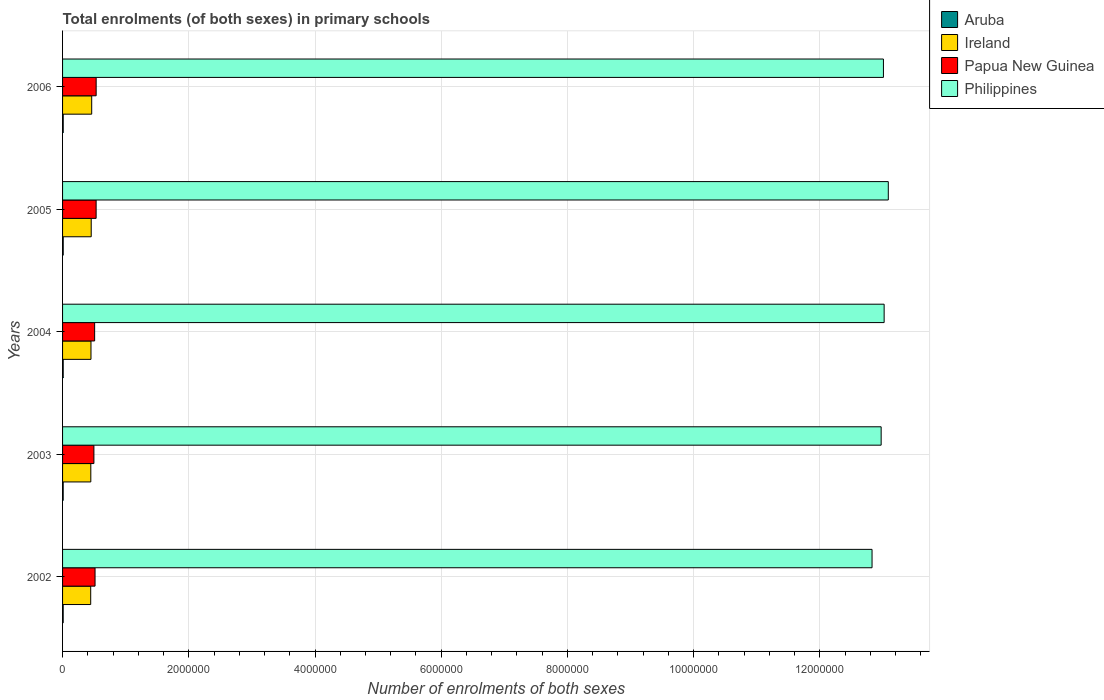How many bars are there on the 1st tick from the top?
Ensure brevity in your answer.  4. How many bars are there on the 2nd tick from the bottom?
Your response must be concise. 4. What is the label of the 3rd group of bars from the top?
Provide a short and direct response. 2004. In how many cases, is the number of bars for a given year not equal to the number of legend labels?
Make the answer very short. 0. What is the number of enrolments in primary schools in Papua New Guinea in 2005?
Keep it short and to the point. 5.32e+05. Across all years, what is the maximum number of enrolments in primary schools in Philippines?
Provide a short and direct response. 1.31e+07. Across all years, what is the minimum number of enrolments in primary schools in Aruba?
Your response must be concise. 9840. What is the total number of enrolments in primary schools in Ireland in the graph?
Offer a very short reply. 2.26e+06. What is the difference between the number of enrolments in primary schools in Philippines in 2002 and that in 2003?
Your answer should be compact. -1.44e+05. What is the difference between the number of enrolments in primary schools in Aruba in 2006 and the number of enrolments in primary schools in Ireland in 2003?
Your response must be concise. -4.37e+05. What is the average number of enrolments in primary schools in Ireland per year?
Your response must be concise. 4.52e+05. In the year 2005, what is the difference between the number of enrolments in primary schools in Papua New Guinea and number of enrolments in primary schools in Ireland?
Provide a succinct answer. 7.77e+04. In how many years, is the number of enrolments in primary schools in Papua New Guinea greater than 10400000 ?
Offer a very short reply. 0. What is the ratio of the number of enrolments in primary schools in Philippines in 2004 to that in 2006?
Your response must be concise. 1. Is the number of enrolments in primary schools in Philippines in 2003 less than that in 2004?
Offer a very short reply. Yes. What is the difference between the highest and the second highest number of enrolments in primary schools in Aruba?
Your answer should be very brief. 140. What is the difference between the highest and the lowest number of enrolments in primary schools in Aruba?
Provide a short and direct response. 550. Is the sum of the number of enrolments in primary schools in Philippines in 2002 and 2006 greater than the maximum number of enrolments in primary schools in Papua New Guinea across all years?
Offer a terse response. Yes. What does the 2nd bar from the top in 2005 represents?
Offer a terse response. Papua New Guinea. What does the 1st bar from the bottom in 2004 represents?
Your answer should be compact. Aruba. Is it the case that in every year, the sum of the number of enrolments in primary schools in Aruba and number of enrolments in primary schools in Ireland is greater than the number of enrolments in primary schools in Papua New Guinea?
Offer a very short reply. No. How many bars are there?
Make the answer very short. 20. Are all the bars in the graph horizontal?
Provide a succinct answer. Yes. How many years are there in the graph?
Give a very brief answer. 5. Does the graph contain any zero values?
Give a very brief answer. No. Where does the legend appear in the graph?
Your answer should be compact. Top right. How are the legend labels stacked?
Make the answer very short. Vertical. What is the title of the graph?
Your answer should be compact. Total enrolments (of both sexes) in primary schools. What is the label or title of the X-axis?
Provide a succinct answer. Number of enrolments of both sexes. What is the label or title of the Y-axis?
Offer a terse response. Years. What is the Number of enrolments of both sexes in Aruba in 2002?
Offer a terse response. 9840. What is the Number of enrolments of both sexes of Ireland in 2002?
Keep it short and to the point. 4.46e+05. What is the Number of enrolments of both sexes of Papua New Guinea in 2002?
Provide a short and direct response. 5.15e+05. What is the Number of enrolments of both sexes in Philippines in 2002?
Keep it short and to the point. 1.28e+07. What is the Number of enrolments of both sexes of Aruba in 2003?
Give a very brief answer. 9897. What is the Number of enrolments of both sexes in Ireland in 2003?
Provide a short and direct response. 4.48e+05. What is the Number of enrolments of both sexes in Papua New Guinea in 2003?
Make the answer very short. 4.97e+05. What is the Number of enrolments of both sexes in Philippines in 2003?
Offer a very short reply. 1.30e+07. What is the Number of enrolments of both sexes in Aruba in 2004?
Offer a terse response. 1.02e+04. What is the Number of enrolments of both sexes in Ireland in 2004?
Make the answer very short. 4.50e+05. What is the Number of enrolments of both sexes in Papua New Guinea in 2004?
Make the answer very short. 5.08e+05. What is the Number of enrolments of both sexes in Philippines in 2004?
Offer a terse response. 1.30e+07. What is the Number of enrolments of both sexes of Aruba in 2005?
Your answer should be very brief. 1.02e+04. What is the Number of enrolments of both sexes of Ireland in 2005?
Give a very brief answer. 4.54e+05. What is the Number of enrolments of both sexes of Papua New Guinea in 2005?
Offer a terse response. 5.32e+05. What is the Number of enrolments of both sexes in Philippines in 2005?
Provide a succinct answer. 1.31e+07. What is the Number of enrolments of both sexes in Aruba in 2006?
Your answer should be compact. 1.04e+04. What is the Number of enrolments of both sexes in Ireland in 2006?
Give a very brief answer. 4.62e+05. What is the Number of enrolments of both sexes of Papua New Guinea in 2006?
Keep it short and to the point. 5.32e+05. What is the Number of enrolments of both sexes of Philippines in 2006?
Your answer should be very brief. 1.30e+07. Across all years, what is the maximum Number of enrolments of both sexes of Aruba?
Offer a terse response. 1.04e+04. Across all years, what is the maximum Number of enrolments of both sexes in Ireland?
Offer a very short reply. 4.62e+05. Across all years, what is the maximum Number of enrolments of both sexes of Papua New Guinea?
Offer a very short reply. 5.32e+05. Across all years, what is the maximum Number of enrolments of both sexes of Philippines?
Give a very brief answer. 1.31e+07. Across all years, what is the minimum Number of enrolments of both sexes of Aruba?
Provide a succinct answer. 9840. Across all years, what is the minimum Number of enrolments of both sexes in Ireland?
Provide a succinct answer. 4.46e+05. Across all years, what is the minimum Number of enrolments of both sexes of Papua New Guinea?
Give a very brief answer. 4.97e+05. Across all years, what is the minimum Number of enrolments of both sexes of Philippines?
Give a very brief answer. 1.28e+07. What is the total Number of enrolments of both sexes in Aruba in the graph?
Ensure brevity in your answer.  5.06e+04. What is the total Number of enrolments of both sexes in Ireland in the graph?
Give a very brief answer. 2.26e+06. What is the total Number of enrolments of both sexes in Papua New Guinea in the graph?
Provide a short and direct response. 2.58e+06. What is the total Number of enrolments of both sexes of Philippines in the graph?
Ensure brevity in your answer.  6.49e+07. What is the difference between the Number of enrolments of both sexes of Aruba in 2002 and that in 2003?
Your answer should be compact. -57. What is the difference between the Number of enrolments of both sexes of Ireland in 2002 and that in 2003?
Give a very brief answer. -1671. What is the difference between the Number of enrolments of both sexes in Papua New Guinea in 2002 and that in 2003?
Provide a short and direct response. 1.81e+04. What is the difference between the Number of enrolments of both sexes of Philippines in 2002 and that in 2003?
Offer a very short reply. -1.44e+05. What is the difference between the Number of enrolments of both sexes in Aruba in 2002 and that in 2004?
Offer a terse response. -345. What is the difference between the Number of enrolments of both sexes in Ireland in 2002 and that in 2004?
Offer a terse response. -4466. What is the difference between the Number of enrolments of both sexes of Papua New Guinea in 2002 and that in 2004?
Provide a short and direct response. 6402. What is the difference between the Number of enrolments of both sexes of Philippines in 2002 and that in 2004?
Give a very brief answer. -1.92e+05. What is the difference between the Number of enrolments of both sexes of Aruba in 2002 and that in 2005?
Provide a succinct answer. -410. What is the difference between the Number of enrolments of both sexes of Ireland in 2002 and that in 2005?
Ensure brevity in your answer.  -8113. What is the difference between the Number of enrolments of both sexes of Papua New Guinea in 2002 and that in 2005?
Provide a short and direct response. -1.70e+04. What is the difference between the Number of enrolments of both sexes in Philippines in 2002 and that in 2005?
Give a very brief answer. -2.58e+05. What is the difference between the Number of enrolments of both sexes in Aruba in 2002 and that in 2006?
Give a very brief answer. -550. What is the difference between the Number of enrolments of both sexes of Ireland in 2002 and that in 2006?
Your response must be concise. -1.56e+04. What is the difference between the Number of enrolments of both sexes of Papua New Guinea in 2002 and that in 2006?
Offer a very short reply. -1.75e+04. What is the difference between the Number of enrolments of both sexes in Philippines in 2002 and that in 2006?
Provide a succinct answer. -1.80e+05. What is the difference between the Number of enrolments of both sexes of Aruba in 2003 and that in 2004?
Keep it short and to the point. -288. What is the difference between the Number of enrolments of both sexes of Ireland in 2003 and that in 2004?
Your response must be concise. -2795. What is the difference between the Number of enrolments of both sexes of Papua New Guinea in 2003 and that in 2004?
Provide a short and direct response. -1.17e+04. What is the difference between the Number of enrolments of both sexes in Philippines in 2003 and that in 2004?
Keep it short and to the point. -4.73e+04. What is the difference between the Number of enrolments of both sexes of Aruba in 2003 and that in 2005?
Provide a succinct answer. -353. What is the difference between the Number of enrolments of both sexes of Ireland in 2003 and that in 2005?
Your answer should be very brief. -6442. What is the difference between the Number of enrolments of both sexes of Papua New Guinea in 2003 and that in 2005?
Provide a short and direct response. -3.51e+04. What is the difference between the Number of enrolments of both sexes in Philippines in 2003 and that in 2005?
Your answer should be compact. -1.13e+05. What is the difference between the Number of enrolments of both sexes of Aruba in 2003 and that in 2006?
Keep it short and to the point. -493. What is the difference between the Number of enrolments of both sexes of Ireland in 2003 and that in 2006?
Make the answer very short. -1.40e+04. What is the difference between the Number of enrolments of both sexes of Papua New Guinea in 2003 and that in 2006?
Give a very brief answer. -3.56e+04. What is the difference between the Number of enrolments of both sexes in Philippines in 2003 and that in 2006?
Offer a terse response. -3.60e+04. What is the difference between the Number of enrolments of both sexes of Aruba in 2004 and that in 2005?
Your response must be concise. -65. What is the difference between the Number of enrolments of both sexes of Ireland in 2004 and that in 2005?
Your answer should be very brief. -3647. What is the difference between the Number of enrolments of both sexes in Papua New Guinea in 2004 and that in 2005?
Provide a short and direct response. -2.34e+04. What is the difference between the Number of enrolments of both sexes in Philippines in 2004 and that in 2005?
Offer a terse response. -6.58e+04. What is the difference between the Number of enrolments of both sexes in Aruba in 2004 and that in 2006?
Offer a terse response. -205. What is the difference between the Number of enrolments of both sexes of Ireland in 2004 and that in 2006?
Your answer should be very brief. -1.12e+04. What is the difference between the Number of enrolments of both sexes in Papua New Guinea in 2004 and that in 2006?
Ensure brevity in your answer.  -2.39e+04. What is the difference between the Number of enrolments of both sexes of Philippines in 2004 and that in 2006?
Provide a succinct answer. 1.13e+04. What is the difference between the Number of enrolments of both sexes in Aruba in 2005 and that in 2006?
Ensure brevity in your answer.  -140. What is the difference between the Number of enrolments of both sexes of Ireland in 2005 and that in 2006?
Your response must be concise. -7528. What is the difference between the Number of enrolments of both sexes in Papua New Guinea in 2005 and that in 2006?
Give a very brief answer. -491. What is the difference between the Number of enrolments of both sexes in Philippines in 2005 and that in 2006?
Your response must be concise. 7.71e+04. What is the difference between the Number of enrolments of both sexes in Aruba in 2002 and the Number of enrolments of both sexes in Ireland in 2003?
Offer a terse response. -4.38e+05. What is the difference between the Number of enrolments of both sexes of Aruba in 2002 and the Number of enrolments of both sexes of Papua New Guinea in 2003?
Your answer should be very brief. -4.87e+05. What is the difference between the Number of enrolments of both sexes of Aruba in 2002 and the Number of enrolments of both sexes of Philippines in 2003?
Provide a succinct answer. -1.30e+07. What is the difference between the Number of enrolments of both sexes in Ireland in 2002 and the Number of enrolments of both sexes in Papua New Guinea in 2003?
Give a very brief answer. -5.07e+04. What is the difference between the Number of enrolments of both sexes in Ireland in 2002 and the Number of enrolments of both sexes in Philippines in 2003?
Your answer should be very brief. -1.25e+07. What is the difference between the Number of enrolments of both sexes of Papua New Guinea in 2002 and the Number of enrolments of both sexes of Philippines in 2003?
Keep it short and to the point. -1.25e+07. What is the difference between the Number of enrolments of both sexes in Aruba in 2002 and the Number of enrolments of both sexes in Ireland in 2004?
Your response must be concise. -4.41e+05. What is the difference between the Number of enrolments of both sexes of Aruba in 2002 and the Number of enrolments of both sexes of Papua New Guinea in 2004?
Your answer should be very brief. -4.98e+05. What is the difference between the Number of enrolments of both sexes of Aruba in 2002 and the Number of enrolments of both sexes of Philippines in 2004?
Keep it short and to the point. -1.30e+07. What is the difference between the Number of enrolments of both sexes of Ireland in 2002 and the Number of enrolments of both sexes of Papua New Guinea in 2004?
Make the answer very short. -6.24e+04. What is the difference between the Number of enrolments of both sexes of Ireland in 2002 and the Number of enrolments of both sexes of Philippines in 2004?
Provide a succinct answer. -1.26e+07. What is the difference between the Number of enrolments of both sexes of Papua New Guinea in 2002 and the Number of enrolments of both sexes of Philippines in 2004?
Your answer should be compact. -1.25e+07. What is the difference between the Number of enrolments of both sexes in Aruba in 2002 and the Number of enrolments of both sexes in Ireland in 2005?
Give a very brief answer. -4.44e+05. What is the difference between the Number of enrolments of both sexes in Aruba in 2002 and the Number of enrolments of both sexes in Papua New Guinea in 2005?
Provide a short and direct response. -5.22e+05. What is the difference between the Number of enrolments of both sexes in Aruba in 2002 and the Number of enrolments of both sexes in Philippines in 2005?
Your answer should be compact. -1.31e+07. What is the difference between the Number of enrolments of both sexes in Ireland in 2002 and the Number of enrolments of both sexes in Papua New Guinea in 2005?
Offer a terse response. -8.58e+04. What is the difference between the Number of enrolments of both sexes of Ireland in 2002 and the Number of enrolments of both sexes of Philippines in 2005?
Make the answer very short. -1.26e+07. What is the difference between the Number of enrolments of both sexes in Papua New Guinea in 2002 and the Number of enrolments of both sexes in Philippines in 2005?
Offer a very short reply. -1.26e+07. What is the difference between the Number of enrolments of both sexes of Aruba in 2002 and the Number of enrolments of both sexes of Ireland in 2006?
Your answer should be compact. -4.52e+05. What is the difference between the Number of enrolments of both sexes in Aruba in 2002 and the Number of enrolments of both sexes in Papua New Guinea in 2006?
Keep it short and to the point. -5.22e+05. What is the difference between the Number of enrolments of both sexes of Aruba in 2002 and the Number of enrolments of both sexes of Philippines in 2006?
Provide a short and direct response. -1.30e+07. What is the difference between the Number of enrolments of both sexes of Ireland in 2002 and the Number of enrolments of both sexes of Papua New Guinea in 2006?
Provide a short and direct response. -8.63e+04. What is the difference between the Number of enrolments of both sexes in Ireland in 2002 and the Number of enrolments of both sexes in Philippines in 2006?
Offer a terse response. -1.26e+07. What is the difference between the Number of enrolments of both sexes in Papua New Guinea in 2002 and the Number of enrolments of both sexes in Philippines in 2006?
Give a very brief answer. -1.25e+07. What is the difference between the Number of enrolments of both sexes of Aruba in 2003 and the Number of enrolments of both sexes of Ireland in 2004?
Offer a very short reply. -4.41e+05. What is the difference between the Number of enrolments of both sexes in Aruba in 2003 and the Number of enrolments of both sexes in Papua New Guinea in 2004?
Offer a very short reply. -4.98e+05. What is the difference between the Number of enrolments of both sexes of Aruba in 2003 and the Number of enrolments of both sexes of Philippines in 2004?
Keep it short and to the point. -1.30e+07. What is the difference between the Number of enrolments of both sexes in Ireland in 2003 and the Number of enrolments of both sexes in Papua New Guinea in 2004?
Your answer should be compact. -6.07e+04. What is the difference between the Number of enrolments of both sexes of Ireland in 2003 and the Number of enrolments of both sexes of Philippines in 2004?
Your answer should be compact. -1.26e+07. What is the difference between the Number of enrolments of both sexes of Papua New Guinea in 2003 and the Number of enrolments of both sexes of Philippines in 2004?
Your answer should be very brief. -1.25e+07. What is the difference between the Number of enrolments of both sexes in Aruba in 2003 and the Number of enrolments of both sexes in Ireland in 2005?
Offer a very short reply. -4.44e+05. What is the difference between the Number of enrolments of both sexes in Aruba in 2003 and the Number of enrolments of both sexes in Papua New Guinea in 2005?
Give a very brief answer. -5.22e+05. What is the difference between the Number of enrolments of both sexes of Aruba in 2003 and the Number of enrolments of both sexes of Philippines in 2005?
Offer a very short reply. -1.31e+07. What is the difference between the Number of enrolments of both sexes of Ireland in 2003 and the Number of enrolments of both sexes of Papua New Guinea in 2005?
Your answer should be very brief. -8.41e+04. What is the difference between the Number of enrolments of both sexes of Ireland in 2003 and the Number of enrolments of both sexes of Philippines in 2005?
Your answer should be compact. -1.26e+07. What is the difference between the Number of enrolments of both sexes in Papua New Guinea in 2003 and the Number of enrolments of both sexes in Philippines in 2005?
Provide a short and direct response. -1.26e+07. What is the difference between the Number of enrolments of both sexes in Aruba in 2003 and the Number of enrolments of both sexes in Ireland in 2006?
Your answer should be very brief. -4.52e+05. What is the difference between the Number of enrolments of both sexes in Aruba in 2003 and the Number of enrolments of both sexes in Papua New Guinea in 2006?
Your response must be concise. -5.22e+05. What is the difference between the Number of enrolments of both sexes in Aruba in 2003 and the Number of enrolments of both sexes in Philippines in 2006?
Your answer should be compact. -1.30e+07. What is the difference between the Number of enrolments of both sexes in Ireland in 2003 and the Number of enrolments of both sexes in Papua New Guinea in 2006?
Offer a terse response. -8.46e+04. What is the difference between the Number of enrolments of both sexes of Ireland in 2003 and the Number of enrolments of both sexes of Philippines in 2006?
Make the answer very short. -1.26e+07. What is the difference between the Number of enrolments of both sexes in Papua New Guinea in 2003 and the Number of enrolments of both sexes in Philippines in 2006?
Keep it short and to the point. -1.25e+07. What is the difference between the Number of enrolments of both sexes of Aruba in 2004 and the Number of enrolments of both sexes of Ireland in 2005?
Make the answer very short. -4.44e+05. What is the difference between the Number of enrolments of both sexes of Aruba in 2004 and the Number of enrolments of both sexes of Papua New Guinea in 2005?
Offer a terse response. -5.22e+05. What is the difference between the Number of enrolments of both sexes in Aruba in 2004 and the Number of enrolments of both sexes in Philippines in 2005?
Offer a very short reply. -1.31e+07. What is the difference between the Number of enrolments of both sexes in Ireland in 2004 and the Number of enrolments of both sexes in Papua New Guinea in 2005?
Your answer should be very brief. -8.13e+04. What is the difference between the Number of enrolments of both sexes of Ireland in 2004 and the Number of enrolments of both sexes of Philippines in 2005?
Ensure brevity in your answer.  -1.26e+07. What is the difference between the Number of enrolments of both sexes in Papua New Guinea in 2004 and the Number of enrolments of both sexes in Philippines in 2005?
Offer a very short reply. -1.26e+07. What is the difference between the Number of enrolments of both sexes of Aruba in 2004 and the Number of enrolments of both sexes of Ireland in 2006?
Provide a succinct answer. -4.51e+05. What is the difference between the Number of enrolments of both sexes in Aruba in 2004 and the Number of enrolments of both sexes in Papua New Guinea in 2006?
Give a very brief answer. -5.22e+05. What is the difference between the Number of enrolments of both sexes in Aruba in 2004 and the Number of enrolments of both sexes in Philippines in 2006?
Your response must be concise. -1.30e+07. What is the difference between the Number of enrolments of both sexes in Ireland in 2004 and the Number of enrolments of both sexes in Papua New Guinea in 2006?
Your answer should be very brief. -8.18e+04. What is the difference between the Number of enrolments of both sexes of Ireland in 2004 and the Number of enrolments of both sexes of Philippines in 2006?
Keep it short and to the point. -1.26e+07. What is the difference between the Number of enrolments of both sexes in Papua New Guinea in 2004 and the Number of enrolments of both sexes in Philippines in 2006?
Your answer should be compact. -1.25e+07. What is the difference between the Number of enrolments of both sexes of Aruba in 2005 and the Number of enrolments of both sexes of Ireland in 2006?
Give a very brief answer. -4.51e+05. What is the difference between the Number of enrolments of both sexes in Aruba in 2005 and the Number of enrolments of both sexes in Papua New Guinea in 2006?
Make the answer very short. -5.22e+05. What is the difference between the Number of enrolments of both sexes in Aruba in 2005 and the Number of enrolments of both sexes in Philippines in 2006?
Make the answer very short. -1.30e+07. What is the difference between the Number of enrolments of both sexes of Ireland in 2005 and the Number of enrolments of both sexes of Papua New Guinea in 2006?
Keep it short and to the point. -7.82e+04. What is the difference between the Number of enrolments of both sexes of Ireland in 2005 and the Number of enrolments of both sexes of Philippines in 2006?
Provide a succinct answer. -1.26e+07. What is the difference between the Number of enrolments of both sexes of Papua New Guinea in 2005 and the Number of enrolments of both sexes of Philippines in 2006?
Provide a succinct answer. -1.25e+07. What is the average Number of enrolments of both sexes of Aruba per year?
Provide a short and direct response. 1.01e+04. What is the average Number of enrolments of both sexes of Ireland per year?
Your response must be concise. 4.52e+05. What is the average Number of enrolments of both sexes of Papua New Guinea per year?
Keep it short and to the point. 5.17e+05. What is the average Number of enrolments of both sexes in Philippines per year?
Keep it short and to the point. 1.30e+07. In the year 2002, what is the difference between the Number of enrolments of both sexes of Aruba and Number of enrolments of both sexes of Ireland?
Provide a succinct answer. -4.36e+05. In the year 2002, what is the difference between the Number of enrolments of both sexes of Aruba and Number of enrolments of both sexes of Papua New Guinea?
Provide a short and direct response. -5.05e+05. In the year 2002, what is the difference between the Number of enrolments of both sexes of Aruba and Number of enrolments of both sexes of Philippines?
Ensure brevity in your answer.  -1.28e+07. In the year 2002, what is the difference between the Number of enrolments of both sexes in Ireland and Number of enrolments of both sexes in Papua New Guinea?
Offer a terse response. -6.88e+04. In the year 2002, what is the difference between the Number of enrolments of both sexes in Ireland and Number of enrolments of both sexes in Philippines?
Give a very brief answer. -1.24e+07. In the year 2002, what is the difference between the Number of enrolments of both sexes of Papua New Guinea and Number of enrolments of both sexes of Philippines?
Your answer should be compact. -1.23e+07. In the year 2003, what is the difference between the Number of enrolments of both sexes of Aruba and Number of enrolments of both sexes of Ireland?
Offer a very short reply. -4.38e+05. In the year 2003, what is the difference between the Number of enrolments of both sexes in Aruba and Number of enrolments of both sexes in Papua New Guinea?
Provide a short and direct response. -4.87e+05. In the year 2003, what is the difference between the Number of enrolments of both sexes in Aruba and Number of enrolments of both sexes in Philippines?
Make the answer very short. -1.30e+07. In the year 2003, what is the difference between the Number of enrolments of both sexes of Ireland and Number of enrolments of both sexes of Papua New Guinea?
Offer a very short reply. -4.90e+04. In the year 2003, what is the difference between the Number of enrolments of both sexes of Ireland and Number of enrolments of both sexes of Philippines?
Ensure brevity in your answer.  -1.25e+07. In the year 2003, what is the difference between the Number of enrolments of both sexes in Papua New Guinea and Number of enrolments of both sexes in Philippines?
Your answer should be very brief. -1.25e+07. In the year 2004, what is the difference between the Number of enrolments of both sexes of Aruba and Number of enrolments of both sexes of Ireland?
Your answer should be very brief. -4.40e+05. In the year 2004, what is the difference between the Number of enrolments of both sexes in Aruba and Number of enrolments of both sexes in Papua New Guinea?
Your answer should be compact. -4.98e+05. In the year 2004, what is the difference between the Number of enrolments of both sexes in Aruba and Number of enrolments of both sexes in Philippines?
Ensure brevity in your answer.  -1.30e+07. In the year 2004, what is the difference between the Number of enrolments of both sexes in Ireland and Number of enrolments of both sexes in Papua New Guinea?
Give a very brief answer. -5.79e+04. In the year 2004, what is the difference between the Number of enrolments of both sexes in Ireland and Number of enrolments of both sexes in Philippines?
Ensure brevity in your answer.  -1.26e+07. In the year 2004, what is the difference between the Number of enrolments of both sexes in Papua New Guinea and Number of enrolments of both sexes in Philippines?
Offer a very short reply. -1.25e+07. In the year 2005, what is the difference between the Number of enrolments of both sexes of Aruba and Number of enrolments of both sexes of Ireland?
Your answer should be very brief. -4.44e+05. In the year 2005, what is the difference between the Number of enrolments of both sexes in Aruba and Number of enrolments of both sexes in Papua New Guinea?
Your answer should be compact. -5.22e+05. In the year 2005, what is the difference between the Number of enrolments of both sexes of Aruba and Number of enrolments of both sexes of Philippines?
Provide a short and direct response. -1.31e+07. In the year 2005, what is the difference between the Number of enrolments of both sexes of Ireland and Number of enrolments of both sexes of Papua New Guinea?
Your response must be concise. -7.77e+04. In the year 2005, what is the difference between the Number of enrolments of both sexes in Ireland and Number of enrolments of both sexes in Philippines?
Offer a very short reply. -1.26e+07. In the year 2005, what is the difference between the Number of enrolments of both sexes of Papua New Guinea and Number of enrolments of both sexes of Philippines?
Ensure brevity in your answer.  -1.26e+07. In the year 2006, what is the difference between the Number of enrolments of both sexes in Aruba and Number of enrolments of both sexes in Ireland?
Your response must be concise. -4.51e+05. In the year 2006, what is the difference between the Number of enrolments of both sexes in Aruba and Number of enrolments of both sexes in Papua New Guinea?
Provide a succinct answer. -5.22e+05. In the year 2006, what is the difference between the Number of enrolments of both sexes of Aruba and Number of enrolments of both sexes of Philippines?
Provide a succinct answer. -1.30e+07. In the year 2006, what is the difference between the Number of enrolments of both sexes in Ireland and Number of enrolments of both sexes in Papua New Guinea?
Your answer should be compact. -7.07e+04. In the year 2006, what is the difference between the Number of enrolments of both sexes of Ireland and Number of enrolments of both sexes of Philippines?
Offer a very short reply. -1.25e+07. In the year 2006, what is the difference between the Number of enrolments of both sexes of Papua New Guinea and Number of enrolments of both sexes of Philippines?
Give a very brief answer. -1.25e+07. What is the ratio of the Number of enrolments of both sexes of Aruba in 2002 to that in 2003?
Ensure brevity in your answer.  0.99. What is the ratio of the Number of enrolments of both sexes of Ireland in 2002 to that in 2003?
Your response must be concise. 1. What is the ratio of the Number of enrolments of both sexes of Papua New Guinea in 2002 to that in 2003?
Give a very brief answer. 1.04. What is the ratio of the Number of enrolments of both sexes in Philippines in 2002 to that in 2003?
Provide a short and direct response. 0.99. What is the ratio of the Number of enrolments of both sexes of Aruba in 2002 to that in 2004?
Make the answer very short. 0.97. What is the ratio of the Number of enrolments of both sexes in Ireland in 2002 to that in 2004?
Give a very brief answer. 0.99. What is the ratio of the Number of enrolments of both sexes of Papua New Guinea in 2002 to that in 2004?
Your response must be concise. 1.01. What is the ratio of the Number of enrolments of both sexes in Ireland in 2002 to that in 2005?
Offer a very short reply. 0.98. What is the ratio of the Number of enrolments of both sexes in Papua New Guinea in 2002 to that in 2005?
Keep it short and to the point. 0.97. What is the ratio of the Number of enrolments of both sexes of Philippines in 2002 to that in 2005?
Keep it short and to the point. 0.98. What is the ratio of the Number of enrolments of both sexes of Aruba in 2002 to that in 2006?
Offer a terse response. 0.95. What is the ratio of the Number of enrolments of both sexes in Ireland in 2002 to that in 2006?
Your answer should be very brief. 0.97. What is the ratio of the Number of enrolments of both sexes of Papua New Guinea in 2002 to that in 2006?
Give a very brief answer. 0.97. What is the ratio of the Number of enrolments of both sexes of Philippines in 2002 to that in 2006?
Keep it short and to the point. 0.99. What is the ratio of the Number of enrolments of both sexes in Aruba in 2003 to that in 2004?
Keep it short and to the point. 0.97. What is the ratio of the Number of enrolments of both sexes of Ireland in 2003 to that in 2004?
Your answer should be very brief. 0.99. What is the ratio of the Number of enrolments of both sexes in Papua New Guinea in 2003 to that in 2004?
Your answer should be compact. 0.98. What is the ratio of the Number of enrolments of both sexes in Aruba in 2003 to that in 2005?
Make the answer very short. 0.97. What is the ratio of the Number of enrolments of both sexes in Ireland in 2003 to that in 2005?
Make the answer very short. 0.99. What is the ratio of the Number of enrolments of both sexes in Papua New Guinea in 2003 to that in 2005?
Your response must be concise. 0.93. What is the ratio of the Number of enrolments of both sexes of Aruba in 2003 to that in 2006?
Ensure brevity in your answer.  0.95. What is the ratio of the Number of enrolments of both sexes in Ireland in 2003 to that in 2006?
Ensure brevity in your answer.  0.97. What is the ratio of the Number of enrolments of both sexes of Papua New Guinea in 2003 to that in 2006?
Your response must be concise. 0.93. What is the ratio of the Number of enrolments of both sexes of Ireland in 2004 to that in 2005?
Your answer should be very brief. 0.99. What is the ratio of the Number of enrolments of both sexes of Papua New Guinea in 2004 to that in 2005?
Provide a short and direct response. 0.96. What is the ratio of the Number of enrolments of both sexes in Aruba in 2004 to that in 2006?
Provide a short and direct response. 0.98. What is the ratio of the Number of enrolments of both sexes in Ireland in 2004 to that in 2006?
Offer a very short reply. 0.98. What is the ratio of the Number of enrolments of both sexes of Papua New Guinea in 2004 to that in 2006?
Give a very brief answer. 0.96. What is the ratio of the Number of enrolments of both sexes in Aruba in 2005 to that in 2006?
Offer a terse response. 0.99. What is the ratio of the Number of enrolments of both sexes in Ireland in 2005 to that in 2006?
Your response must be concise. 0.98. What is the ratio of the Number of enrolments of both sexes in Papua New Guinea in 2005 to that in 2006?
Give a very brief answer. 1. What is the ratio of the Number of enrolments of both sexes of Philippines in 2005 to that in 2006?
Offer a very short reply. 1.01. What is the difference between the highest and the second highest Number of enrolments of both sexes in Aruba?
Provide a succinct answer. 140. What is the difference between the highest and the second highest Number of enrolments of both sexes of Ireland?
Your answer should be very brief. 7528. What is the difference between the highest and the second highest Number of enrolments of both sexes in Papua New Guinea?
Offer a terse response. 491. What is the difference between the highest and the second highest Number of enrolments of both sexes of Philippines?
Make the answer very short. 6.58e+04. What is the difference between the highest and the lowest Number of enrolments of both sexes in Aruba?
Your answer should be compact. 550. What is the difference between the highest and the lowest Number of enrolments of both sexes of Ireland?
Offer a very short reply. 1.56e+04. What is the difference between the highest and the lowest Number of enrolments of both sexes of Papua New Guinea?
Provide a short and direct response. 3.56e+04. What is the difference between the highest and the lowest Number of enrolments of both sexes in Philippines?
Keep it short and to the point. 2.58e+05. 